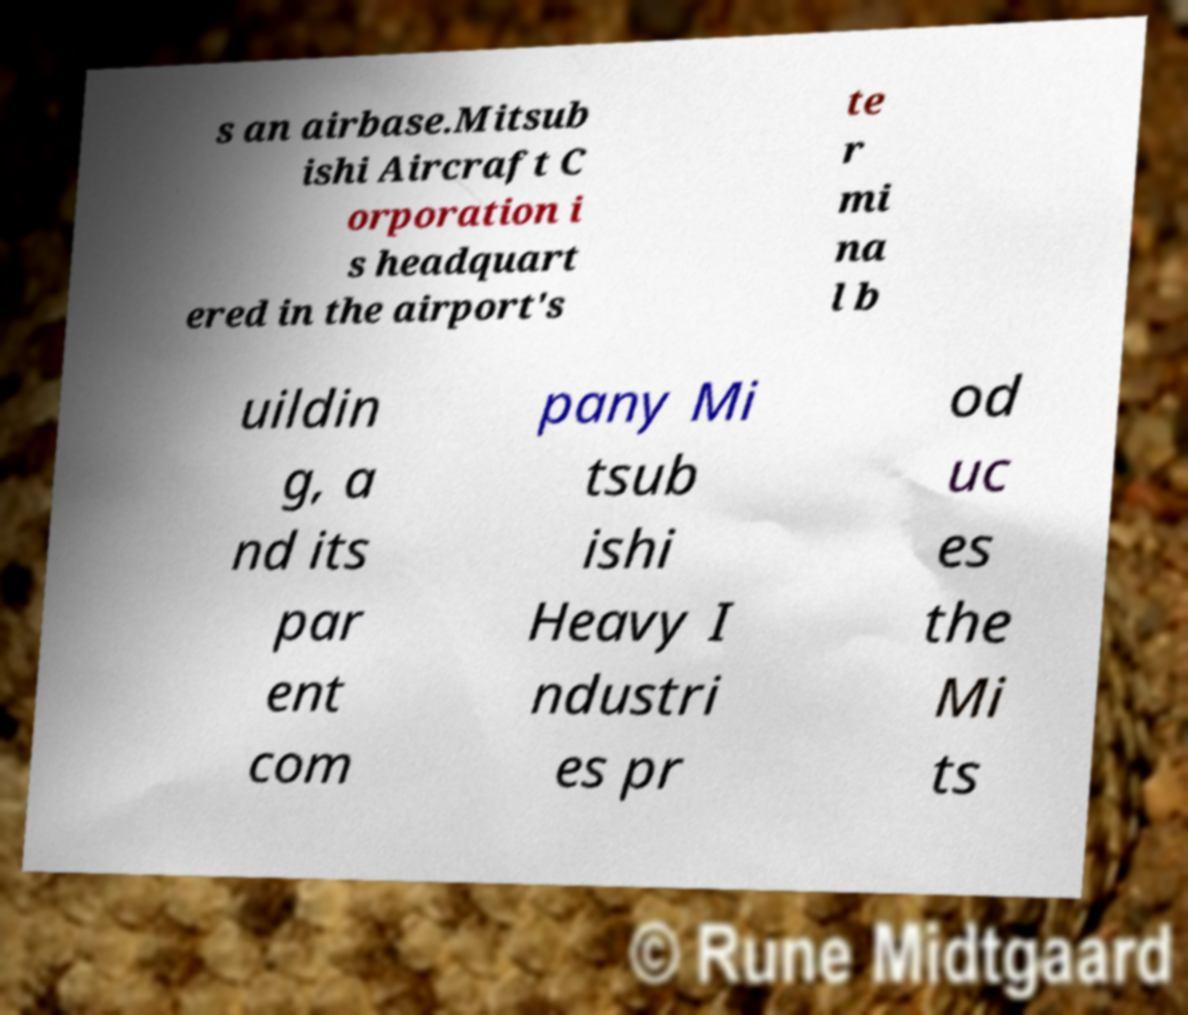Can you read and provide the text displayed in the image?This photo seems to have some interesting text. Can you extract and type it out for me? s an airbase.Mitsub ishi Aircraft C orporation i s headquart ered in the airport's te r mi na l b uildin g, a nd its par ent com pany Mi tsub ishi Heavy I ndustri es pr od uc es the Mi ts 